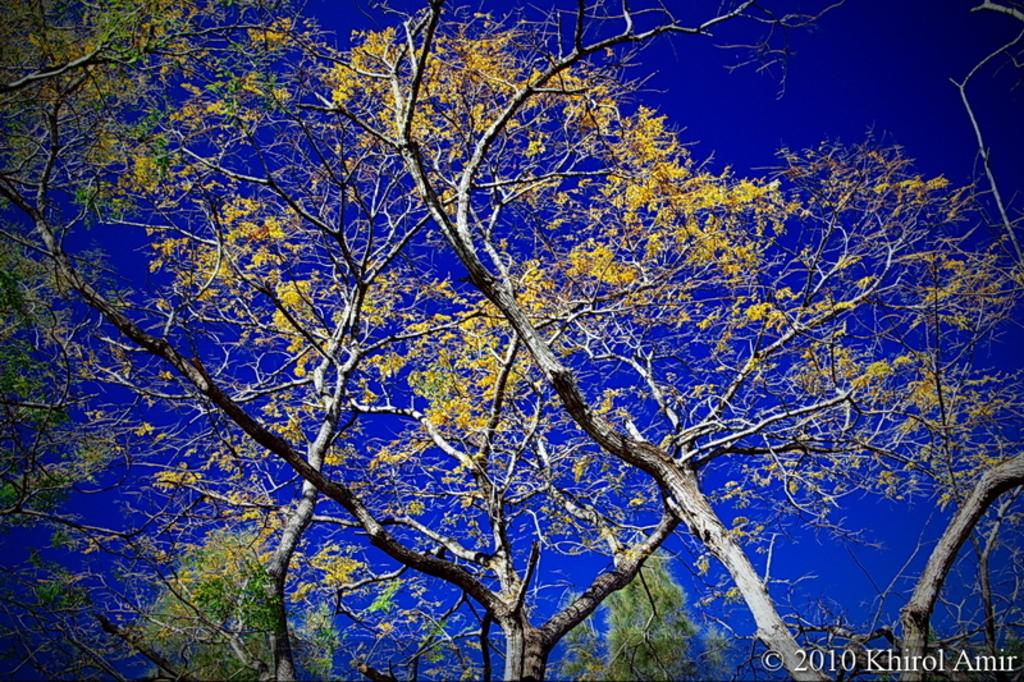What type of vegetation can be seen in the image? There are trees in the image. What additional features can be observed on the trees? There are flowers on the trees. Is there a volcano erupting in the background of the image? No, there is no volcano present in the image. 